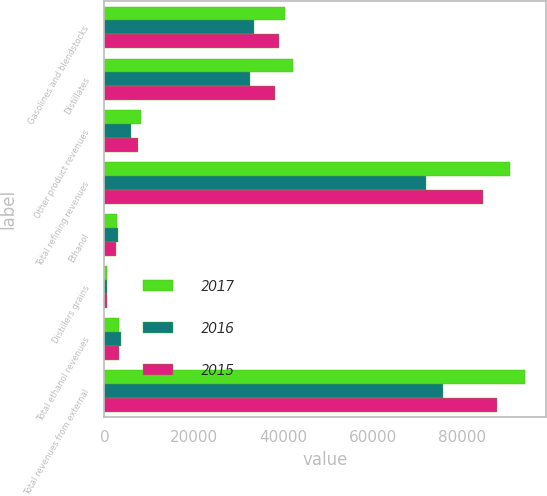<chart> <loc_0><loc_0><loc_500><loc_500><stacked_bar_chart><ecel><fcel>Gasolines and blendstocks<fcel>Distillates<fcel>Other product revenues<fcel>Total refining revenues<fcel>Ethanol<fcel>Distillers grains<fcel>Total ethanol revenues<fcel>Total revenues from external<nl><fcel>2017<fcel>40362<fcel>42074<fcel>8215<fcel>90651<fcel>2764<fcel>560<fcel>3324<fcel>93980<nl><fcel>2016<fcel>33450<fcel>32576<fcel>5942<fcel>71968<fcel>3105<fcel>586<fcel>3691<fcel>75659<nl><fcel>2015<fcel>38983<fcel>38093<fcel>7445<fcel>84521<fcel>2628<fcel>655<fcel>3283<fcel>87804<nl></chart> 